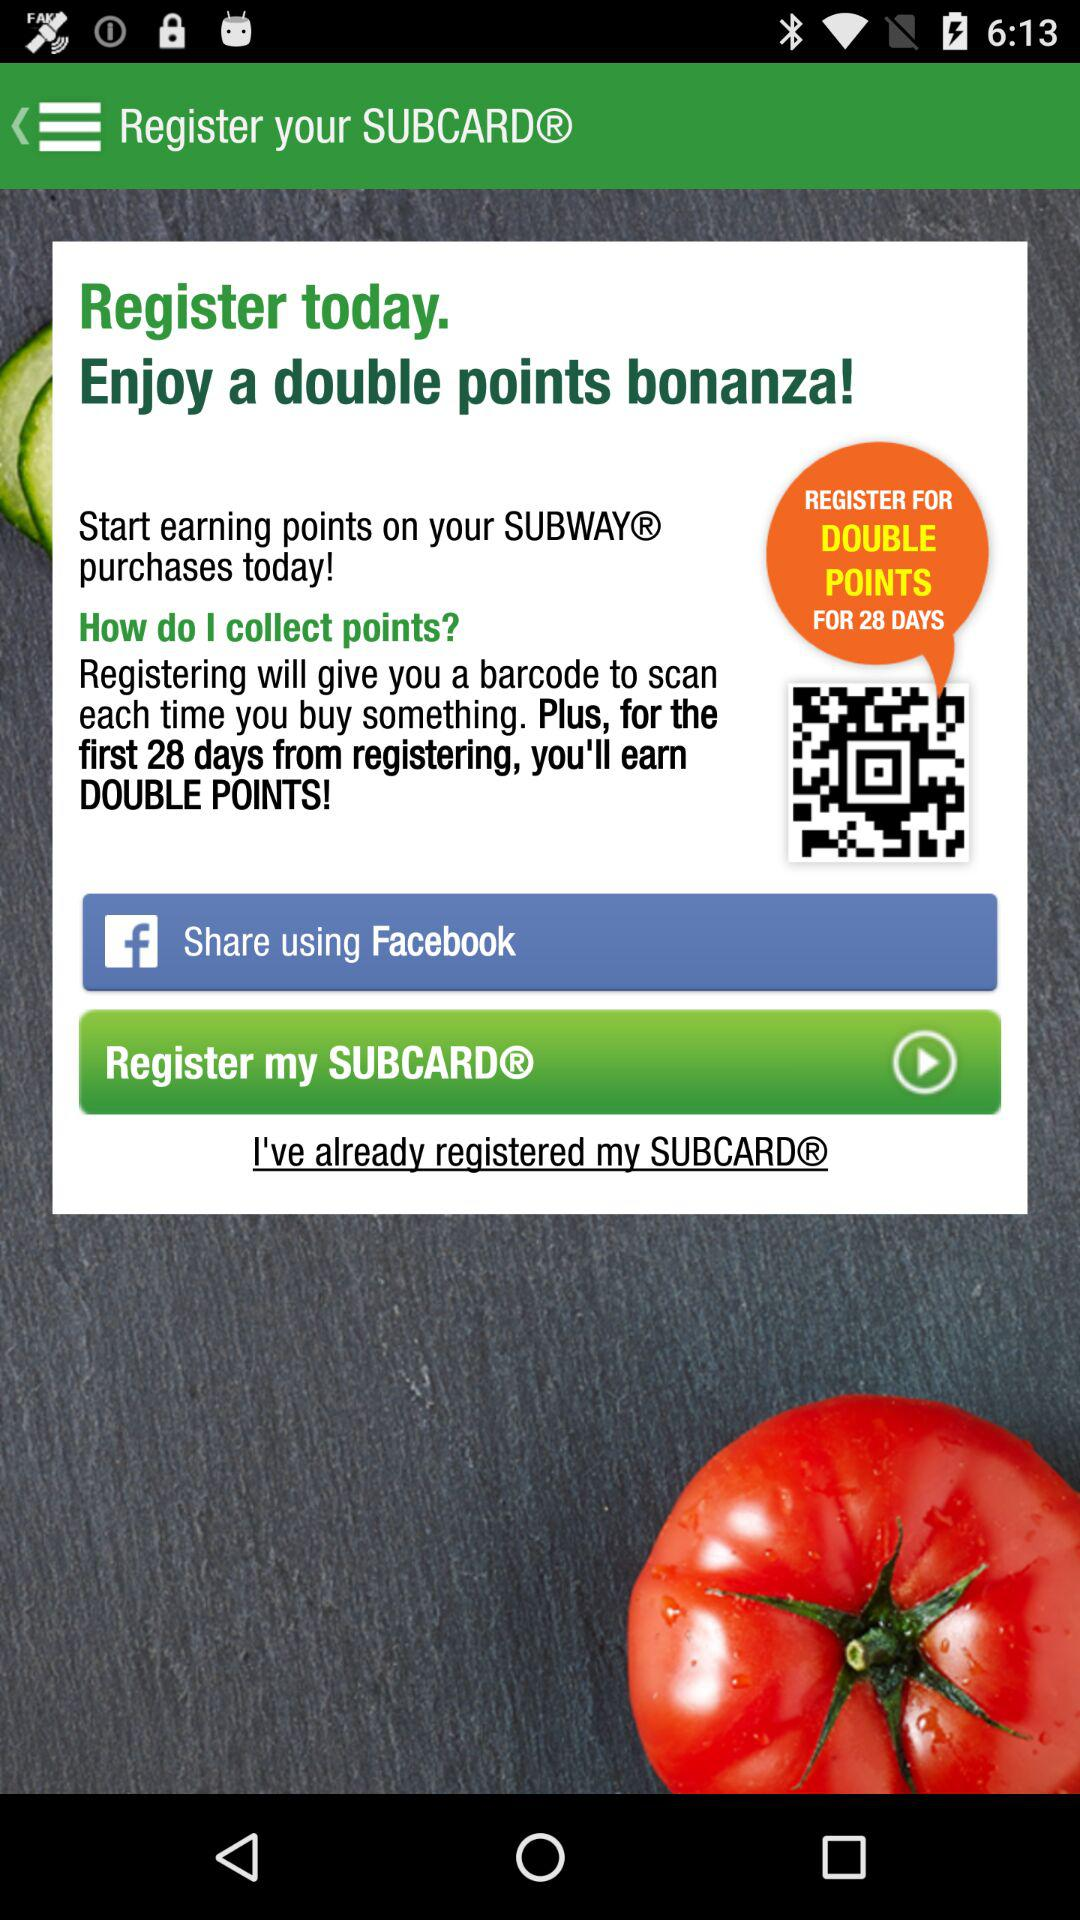What is the user's SUBCARD number?
When the provided information is insufficient, respond with <no answer>. <no answer> 